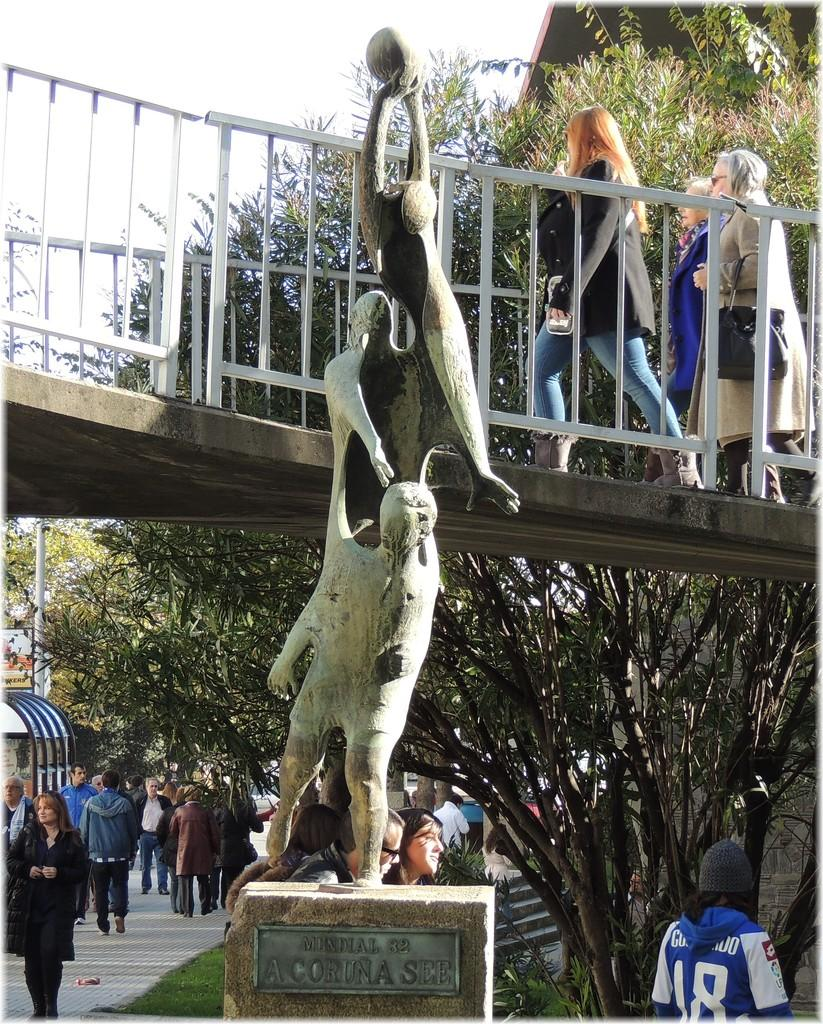<image>
Relay a brief, clear account of the picture shown. A statue is identified with a Mundial 82 sign. 